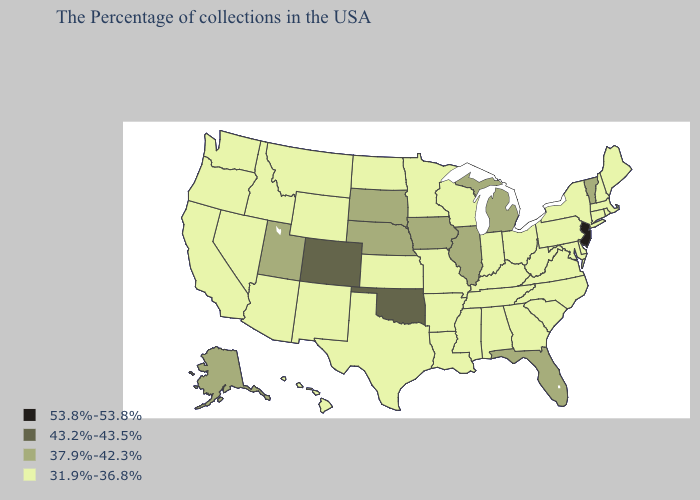Does Iowa have a lower value than Kansas?
Concise answer only. No. Does Colorado have the lowest value in the USA?
Quick response, please. No. Does the map have missing data?
Concise answer only. No. Does the map have missing data?
Be succinct. No. Name the states that have a value in the range 53.8%-53.8%?
Quick response, please. New Jersey. Does Oklahoma have the lowest value in the South?
Give a very brief answer. No. Which states have the lowest value in the Northeast?
Write a very short answer. Maine, Massachusetts, Rhode Island, New Hampshire, Connecticut, New York, Pennsylvania. What is the value of Rhode Island?
Quick response, please. 31.9%-36.8%. Among the states that border Georgia , does Alabama have the highest value?
Keep it brief. No. What is the highest value in states that border Mississippi?
Short answer required. 31.9%-36.8%. Name the states that have a value in the range 37.9%-42.3%?
Write a very short answer. Vermont, Florida, Michigan, Illinois, Iowa, Nebraska, South Dakota, Utah, Alaska. What is the value of Ohio?
Be succinct. 31.9%-36.8%. What is the value of North Dakota?
Write a very short answer. 31.9%-36.8%. What is the value of Pennsylvania?
Be succinct. 31.9%-36.8%. Which states have the lowest value in the Northeast?
Give a very brief answer. Maine, Massachusetts, Rhode Island, New Hampshire, Connecticut, New York, Pennsylvania. 